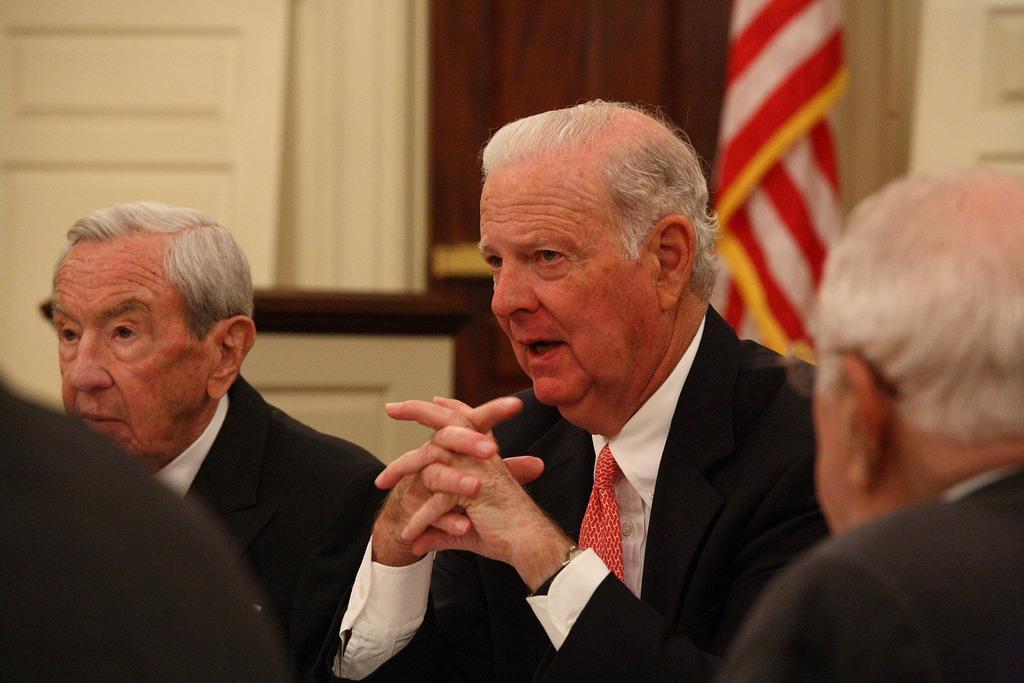In one or two sentences, can you explain what this image depicts? In the picture we can see some men are sitting on the chairs and they are wearing a blazer, ties and shirts and in the background we can see a flag and a wall. 